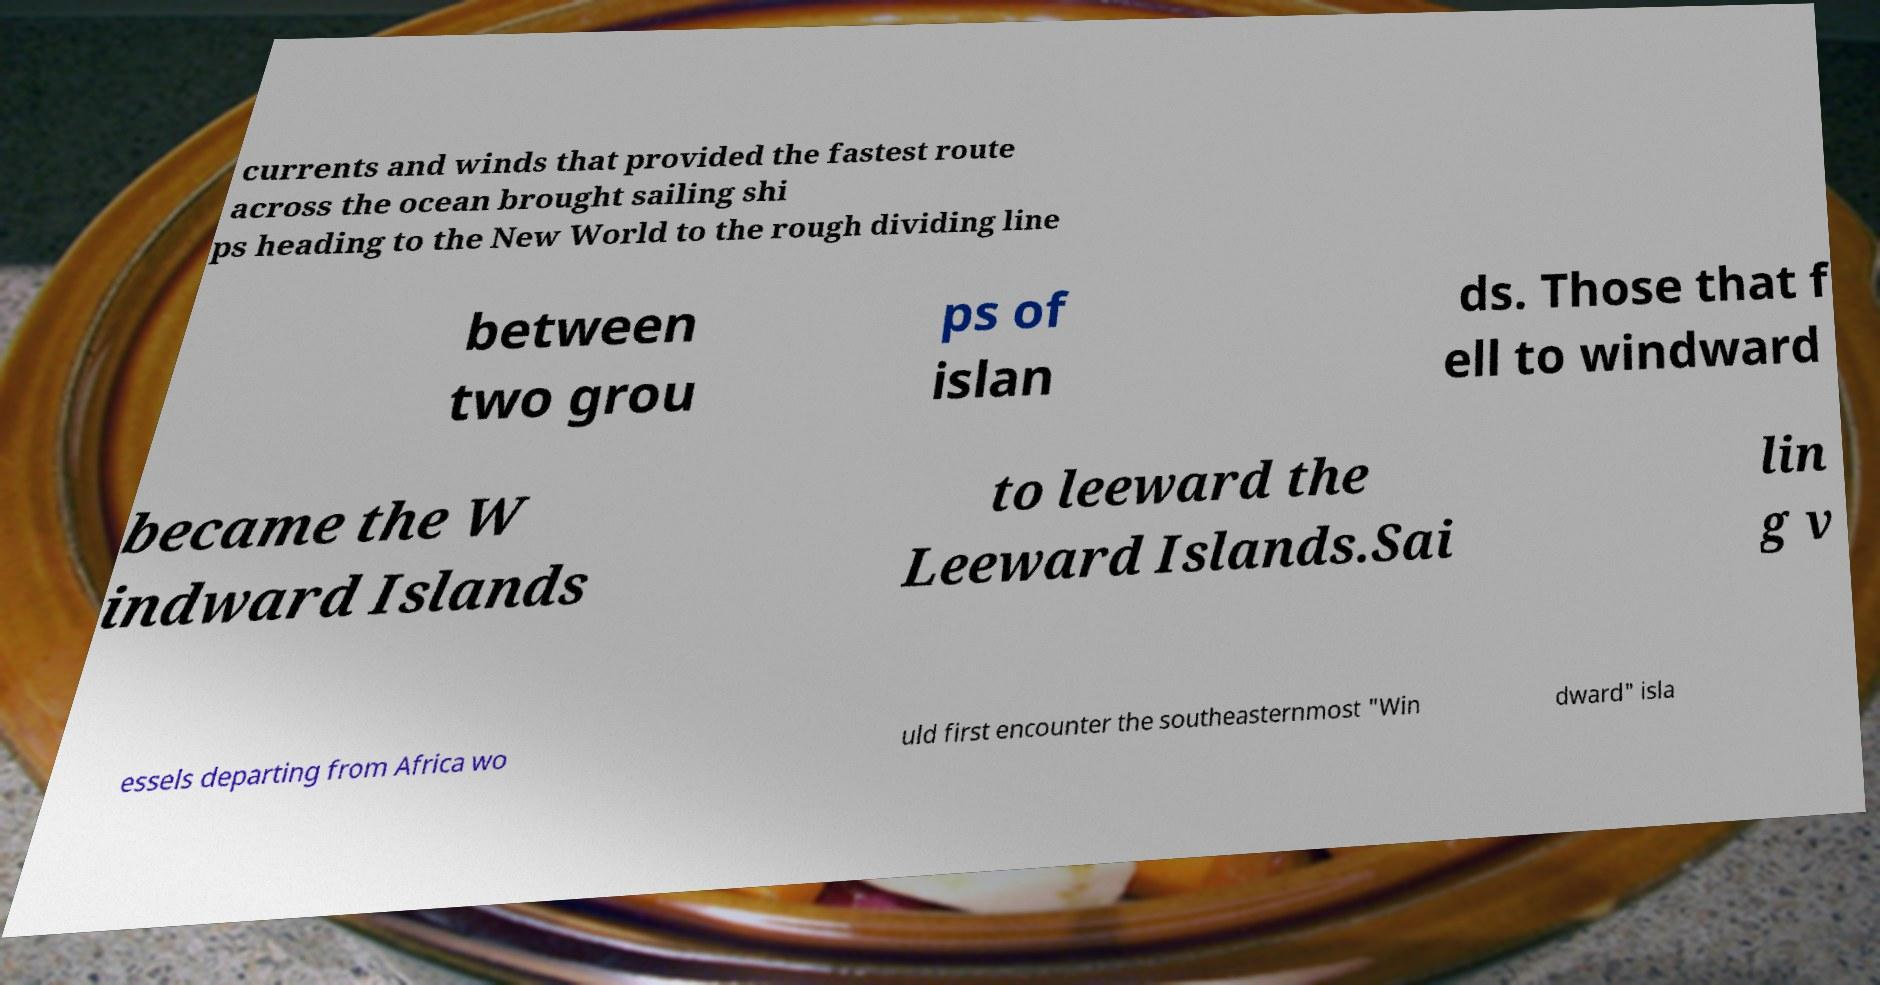I need the written content from this picture converted into text. Can you do that? currents and winds that provided the fastest route across the ocean brought sailing shi ps heading to the New World to the rough dividing line between two grou ps of islan ds. Those that f ell to windward became the W indward Islands to leeward the Leeward Islands.Sai lin g v essels departing from Africa wo uld first encounter the southeasternmost "Win dward" isla 